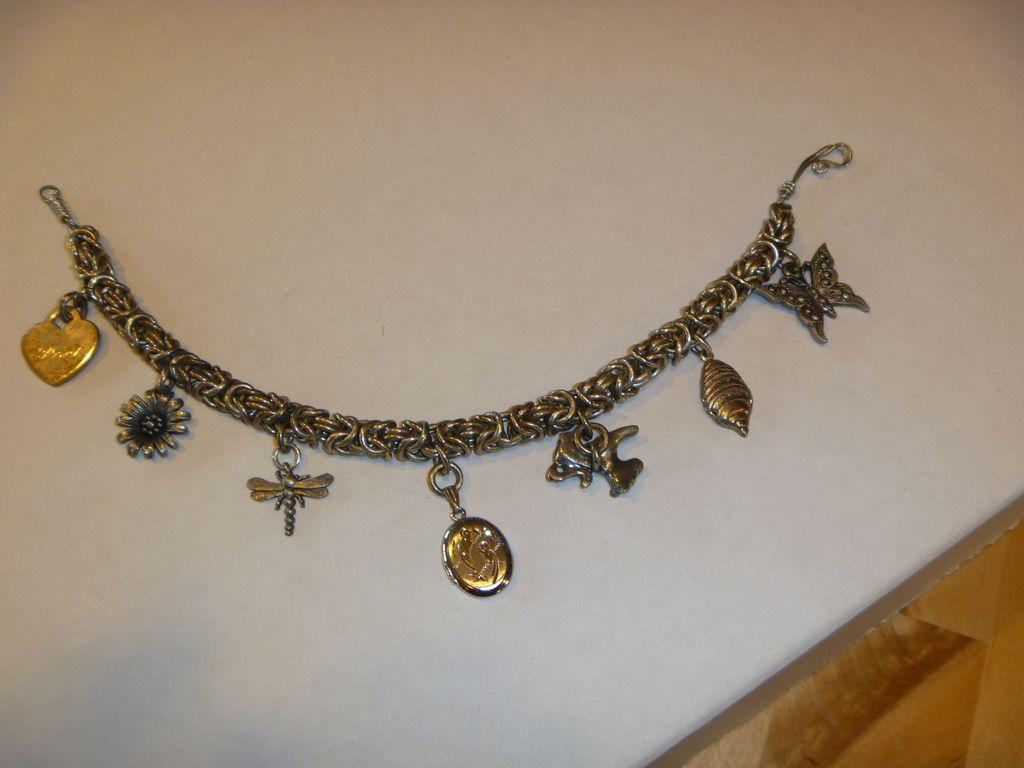What is the main subject of the image? The main subject of the image is a bracelet with different pendants. What is the background color or appearance in the image? There is a white background in the image. What type of flooring is visible in the image? There is a wooden floor visible in the bottom right corner of the image. How many trees can be seen in the image? There are no trees visible in the image; it features a bracelet with different pendants against a white background. What is the hand doing with the bracelet in the image? There is no hand present in the image; it only shows the bracelet with different pendants against a white background. 